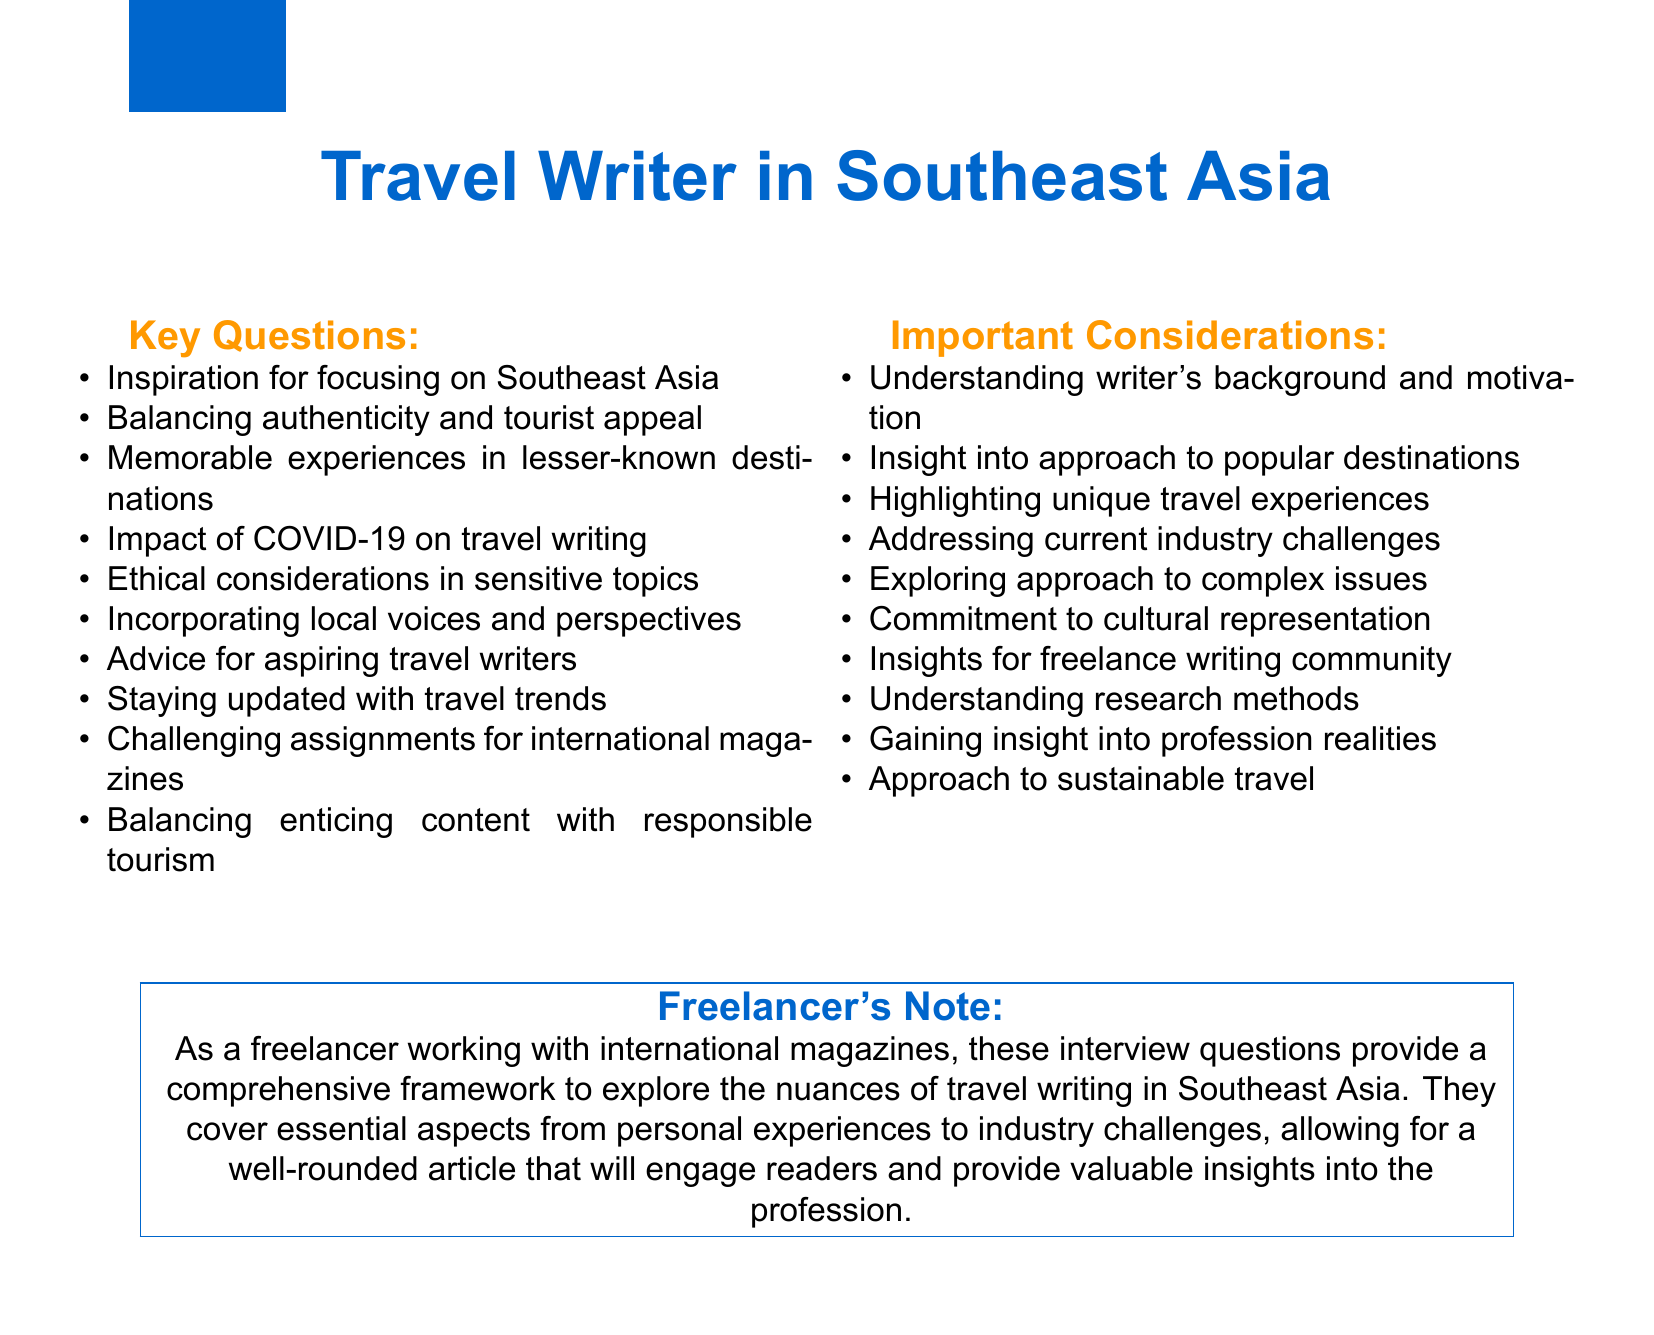What is the title of the notes? The title states the focus of the notes, which is about travel writing in a specific region.
Answer: Travel Writer in Southeast Asia How many key questions are listed in the document? The document outlines a total of ten key questions that guide the interview process.
Answer: 10 What is one of the key questions related to current industry challenges? The document highlights important considerations which relate to the impacts of recent events on the industry.
Answer: Impact of COVID-19 on travel writing What color is used for the header and key questions? The document specifies colors to be used for visual elements, including headings.
Answer: Main color What ethical considerations are mentioned for travel writing? The document addresses complex issues that writers must navigate when reporting on sensitive topics.
Answer: Sensitive topics Which country is cited as an example for a lesser-known destination? The document mentions specific countries to highlight unique travel experiences in Southeast Asia.
Answer: Laos What advice is offered to aspiring travel writers? The document provides key suggestions for those looking to enter the field of travel writing in the region.
Answer: Advice for aspiring travel writers What does the freelancer's note emphasize? The final section of the document focuses on the significance of the questions posed in relation to the industry.
Answer: Comprehensive framework Which two popular destinations are discussed in relation to tourist appeal? The document points out well-known sites that require a careful balance in writing.
Answer: Angkor Wat, Halong Bay 